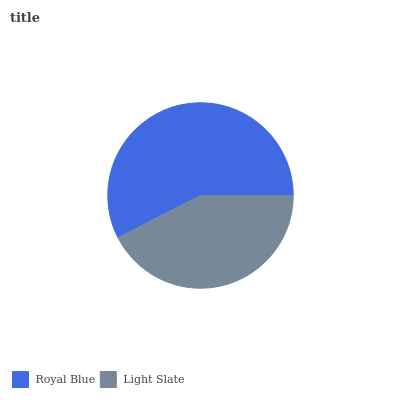Is Light Slate the minimum?
Answer yes or no. Yes. Is Royal Blue the maximum?
Answer yes or no. Yes. Is Light Slate the maximum?
Answer yes or no. No. Is Royal Blue greater than Light Slate?
Answer yes or no. Yes. Is Light Slate less than Royal Blue?
Answer yes or no. Yes. Is Light Slate greater than Royal Blue?
Answer yes or no. No. Is Royal Blue less than Light Slate?
Answer yes or no. No. Is Royal Blue the high median?
Answer yes or no. Yes. Is Light Slate the low median?
Answer yes or no. Yes. Is Light Slate the high median?
Answer yes or no. No. Is Royal Blue the low median?
Answer yes or no. No. 